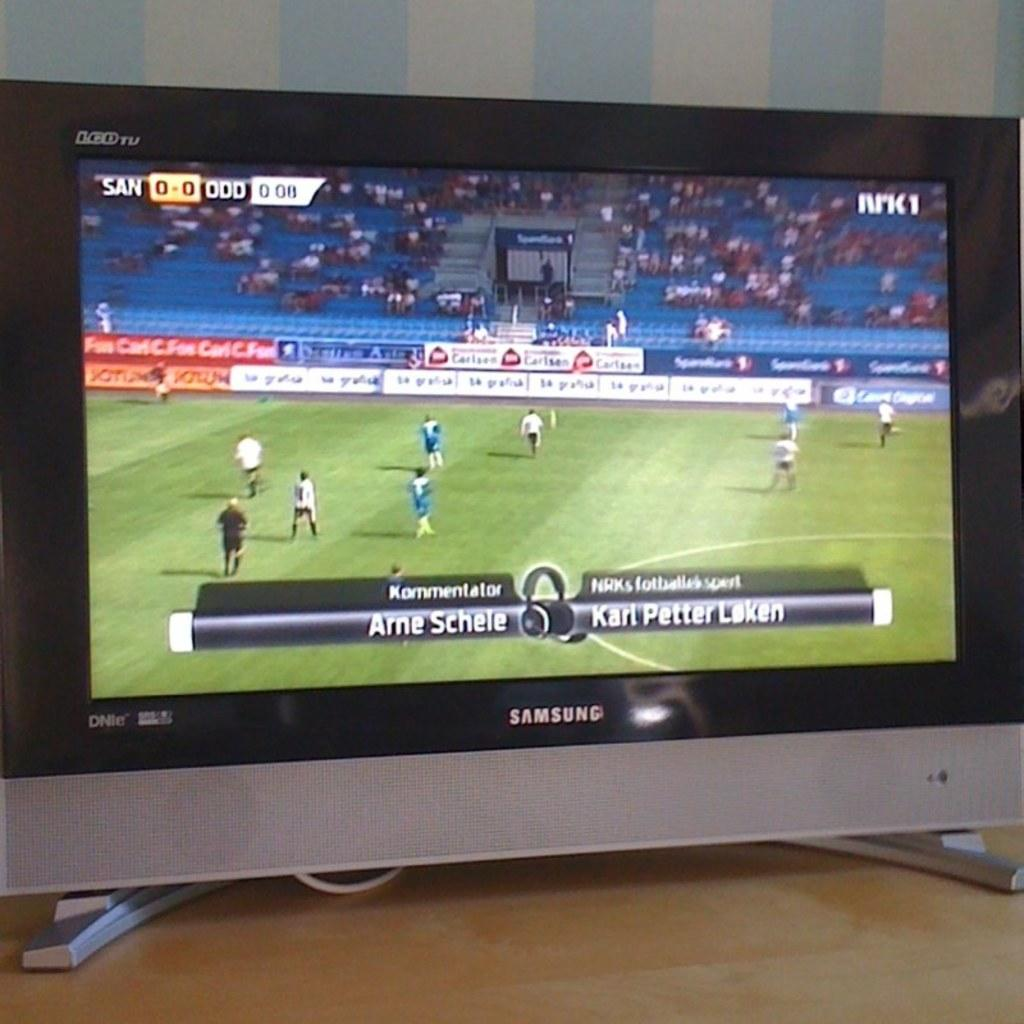<image>
Summarize the visual content of the image. A samsung television that has a soccer game going on. 